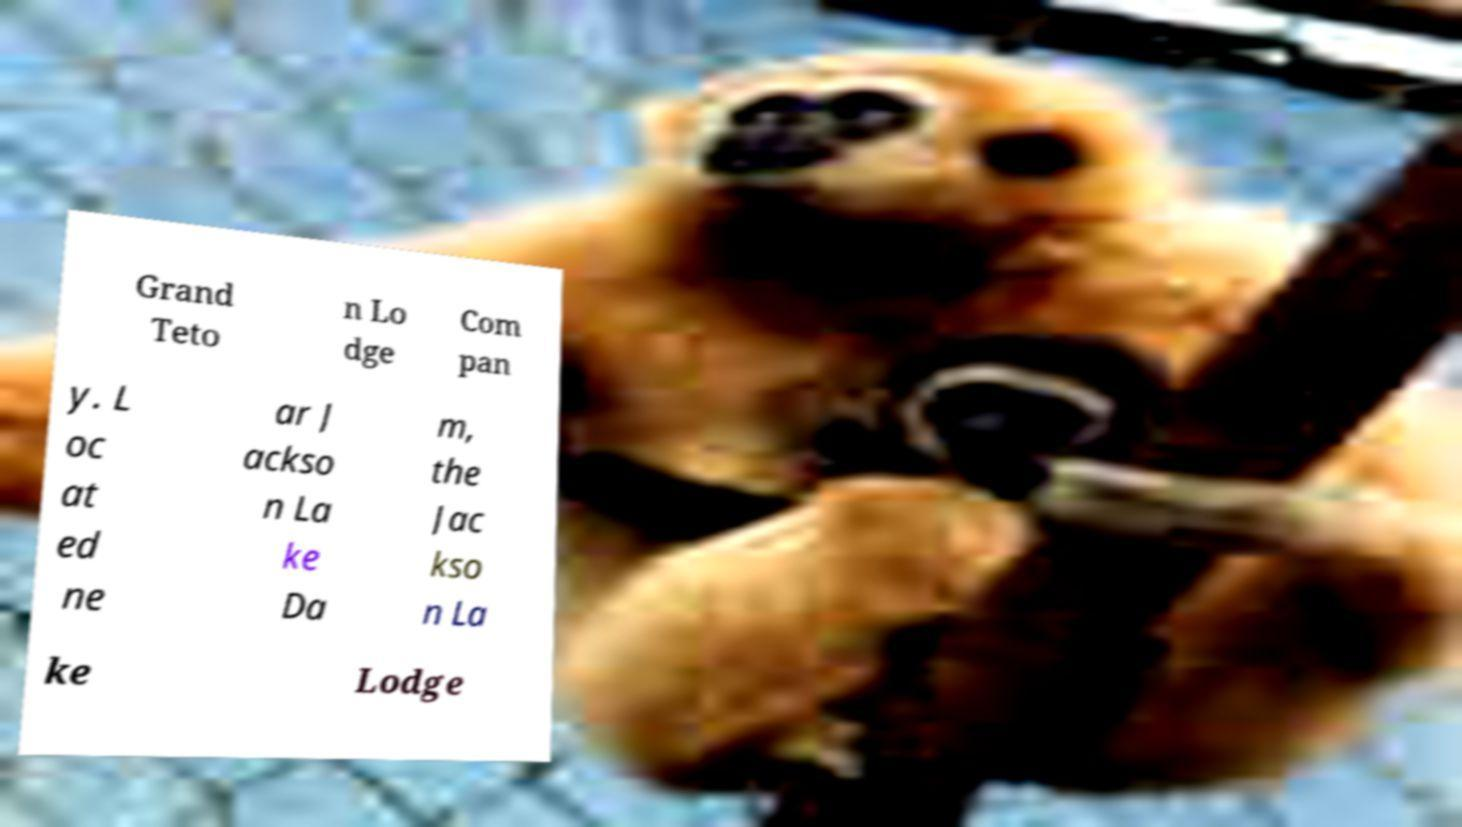There's text embedded in this image that I need extracted. Can you transcribe it verbatim? Grand Teto n Lo dge Com pan y. L oc at ed ne ar J ackso n La ke Da m, the Jac kso n La ke Lodge 